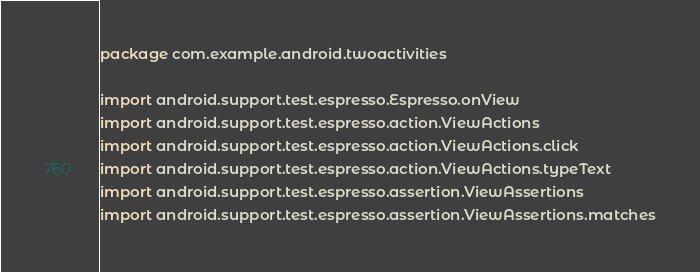Convert code to text. <code><loc_0><loc_0><loc_500><loc_500><_Kotlin_>package com.example.android.twoactivities

import android.support.test.espresso.Espresso.onView
import android.support.test.espresso.action.ViewActions
import android.support.test.espresso.action.ViewActions.click
import android.support.test.espresso.action.ViewActions.typeText
import android.support.test.espresso.assertion.ViewAssertions
import android.support.test.espresso.assertion.ViewAssertions.matches</code> 